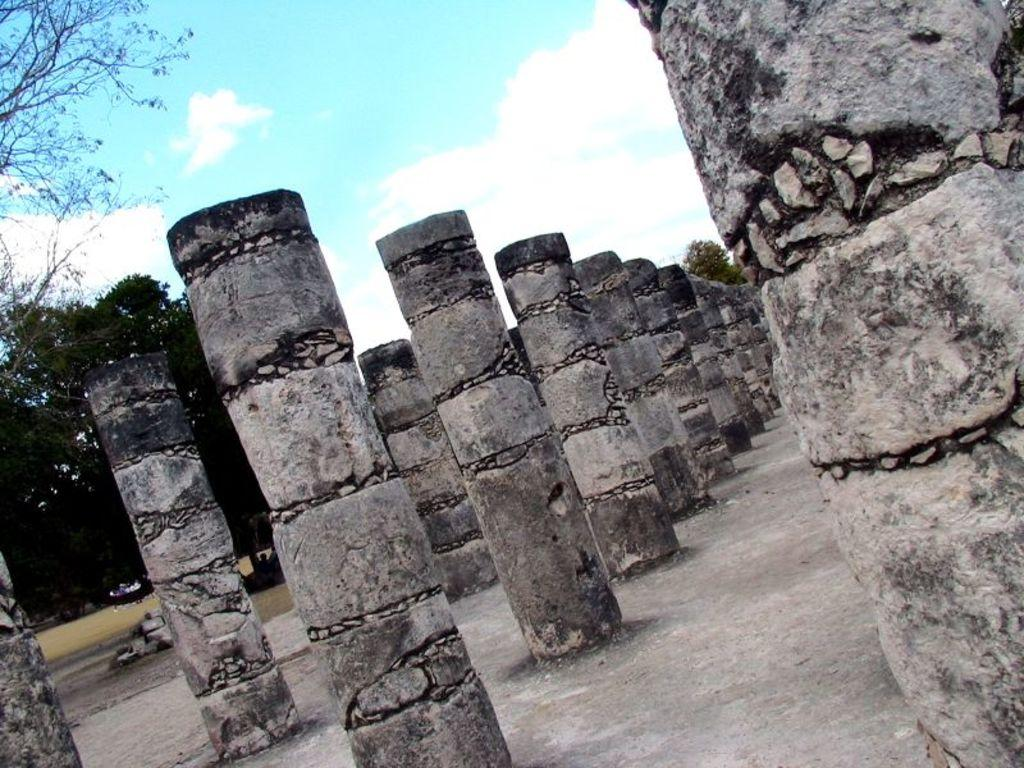What type of structure is visible in the image? There are cement pillars in the image. How are the pillars arranged? The pillars are constructed in an order. What is the shape of the pillars? The pillars are cylindrical in shape. What can be seen behind the pillars in the image? There are trees behind the pillars in the image. What type of reaction does the bee have when it sees the oatmeal in the image? There is no bee or oatmeal present in the image, so it is not possible to determine any reaction. 